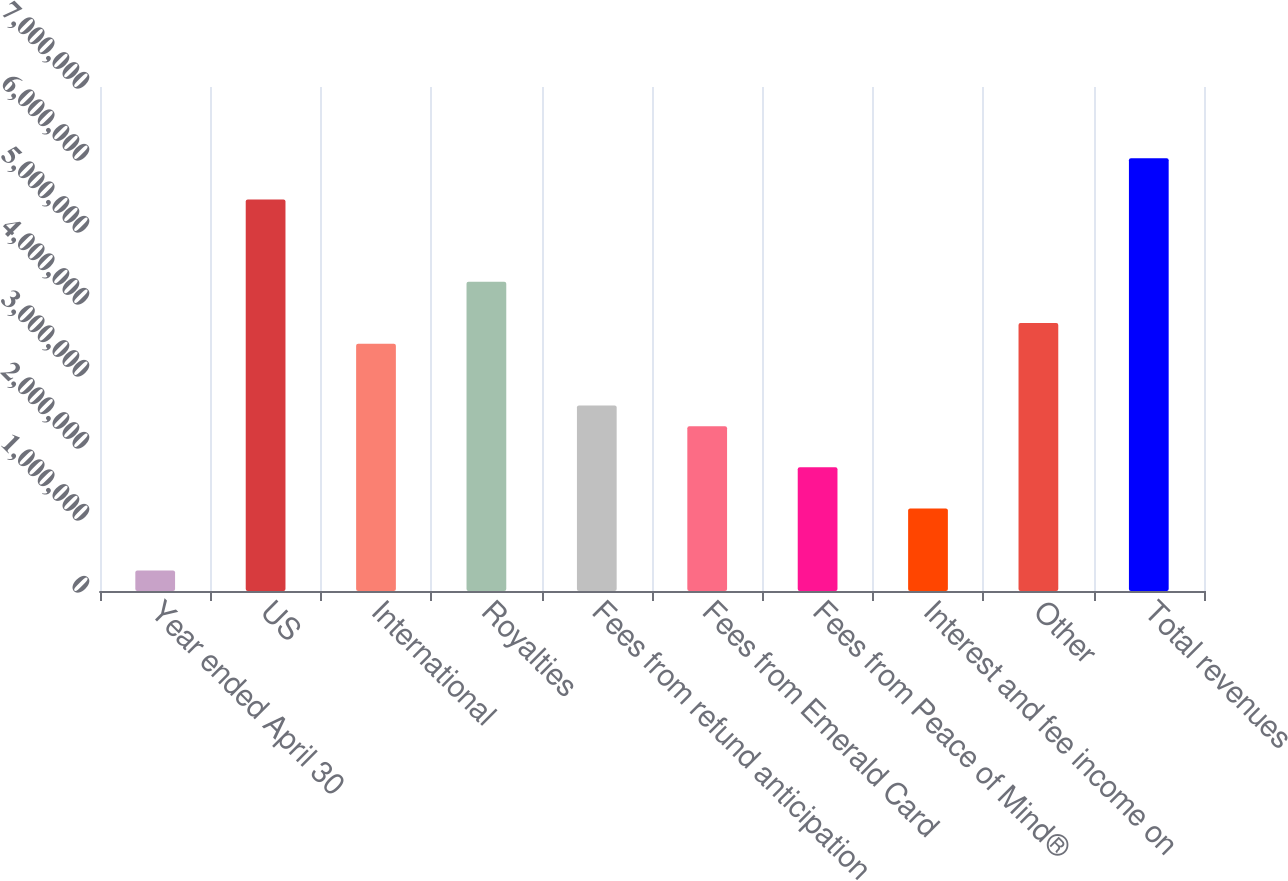Convert chart. <chart><loc_0><loc_0><loc_500><loc_500><bar_chart><fcel>Year ended April 30<fcel>US<fcel>International<fcel>Royalties<fcel>Fees from refund anticipation<fcel>Fees from Emerald Card<fcel>Fees from Peace of Mind®<fcel>Interest and fee income on<fcel>Other<fcel>Total revenues<nl><fcel>286260<fcel>5.4385e+06<fcel>3.43485e+06<fcel>4.29355e+06<fcel>2.57614e+06<fcel>2.28991e+06<fcel>1.71744e+06<fcel>1.14497e+06<fcel>3.72108e+06<fcel>6.01097e+06<nl></chart> 